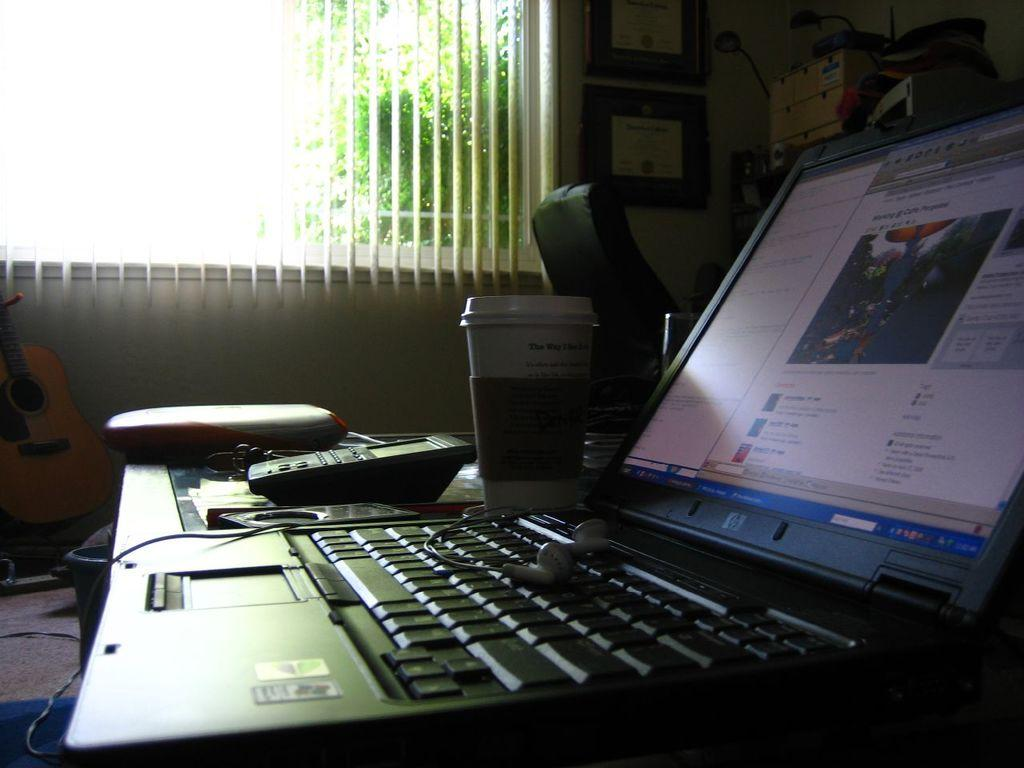What is the main object in the center of the image? There is a table in the center of the image. What items can be seen on the table? On the table, there is a tab and earphones. What can be seen in the background of the image? In the background, there is a window, a photo frame, a machine, a wall, and trees. Can you describe any musical instruments in the image? Yes, there is a guitar in the background. What direction are the birds flying in the image? There are no birds present in the image. How is the connection between the earphones and the device established in the image? The image does not show the connection between the earphones and the device; it only shows the earphones on the table. 